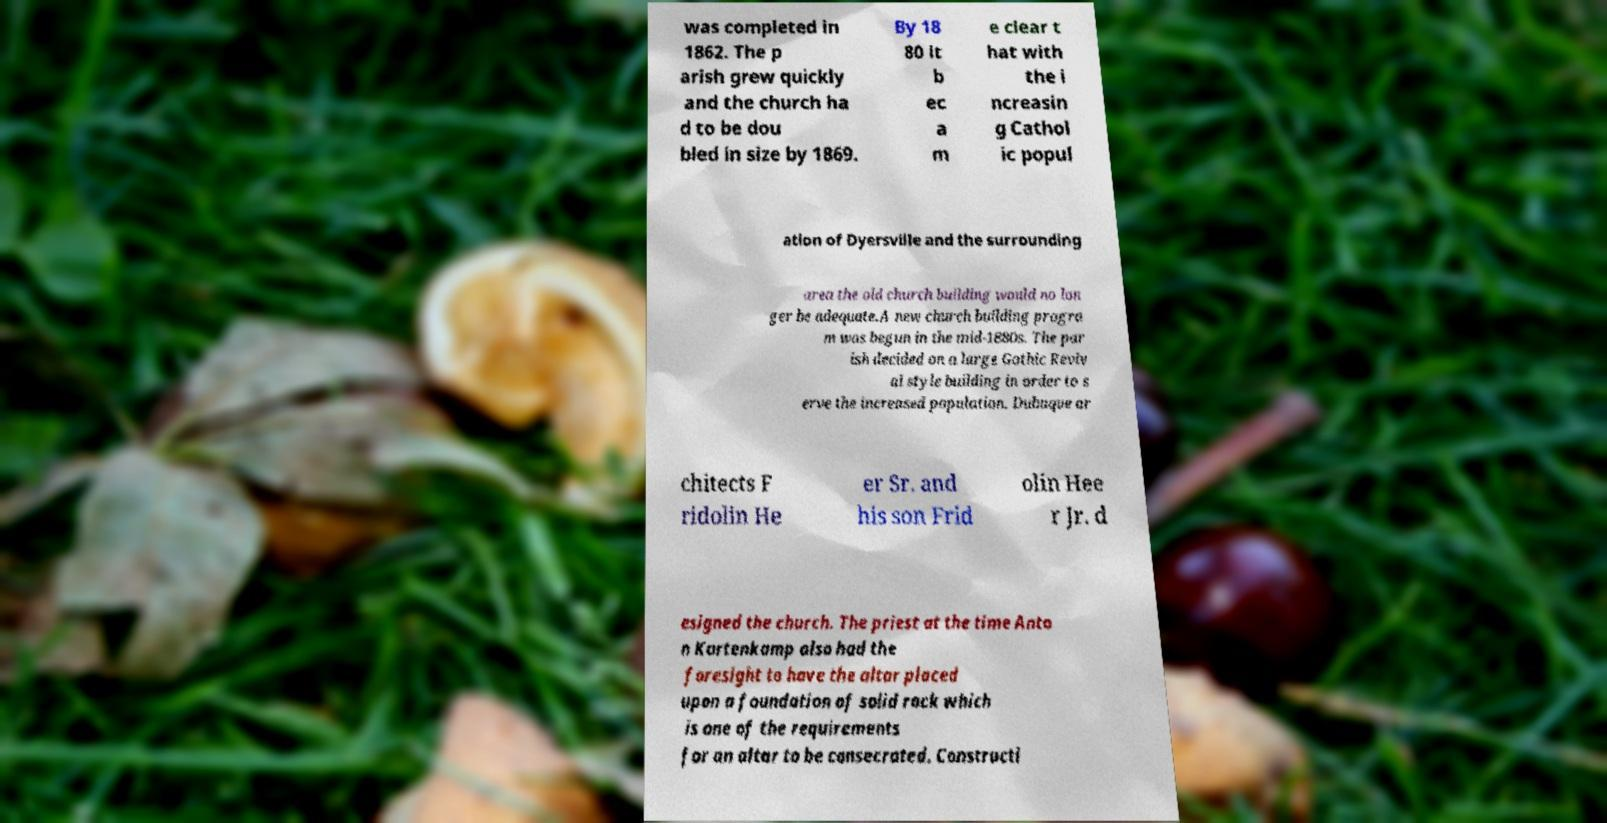Can you accurately transcribe the text from the provided image for me? was completed in 1862. The p arish grew quickly and the church ha d to be dou bled in size by 1869. By 18 80 it b ec a m e clear t hat with the i ncreasin g Cathol ic popul ation of Dyersville and the surrounding area the old church building would no lon ger be adequate.A new church building progra m was begun in the mid-1880s. The par ish decided on a large Gothic Reviv al style building in order to s erve the increased population. Dubuque ar chitects F ridolin He er Sr. and his son Frid olin Hee r Jr. d esigned the church. The priest at the time Anto n Kortenkamp also had the foresight to have the altar placed upon a foundation of solid rock which is one of the requirements for an altar to be consecrated. Constructi 